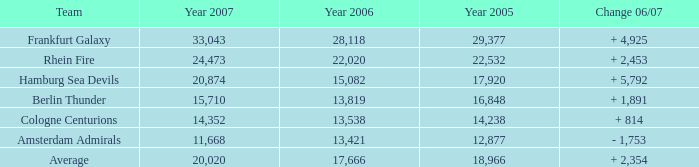Which team is it when the 2007 figure exceeds 15,710, the 2006 figure surpasses 17,666, and the 2005 number is above 22,532? Frankfurt Galaxy. 